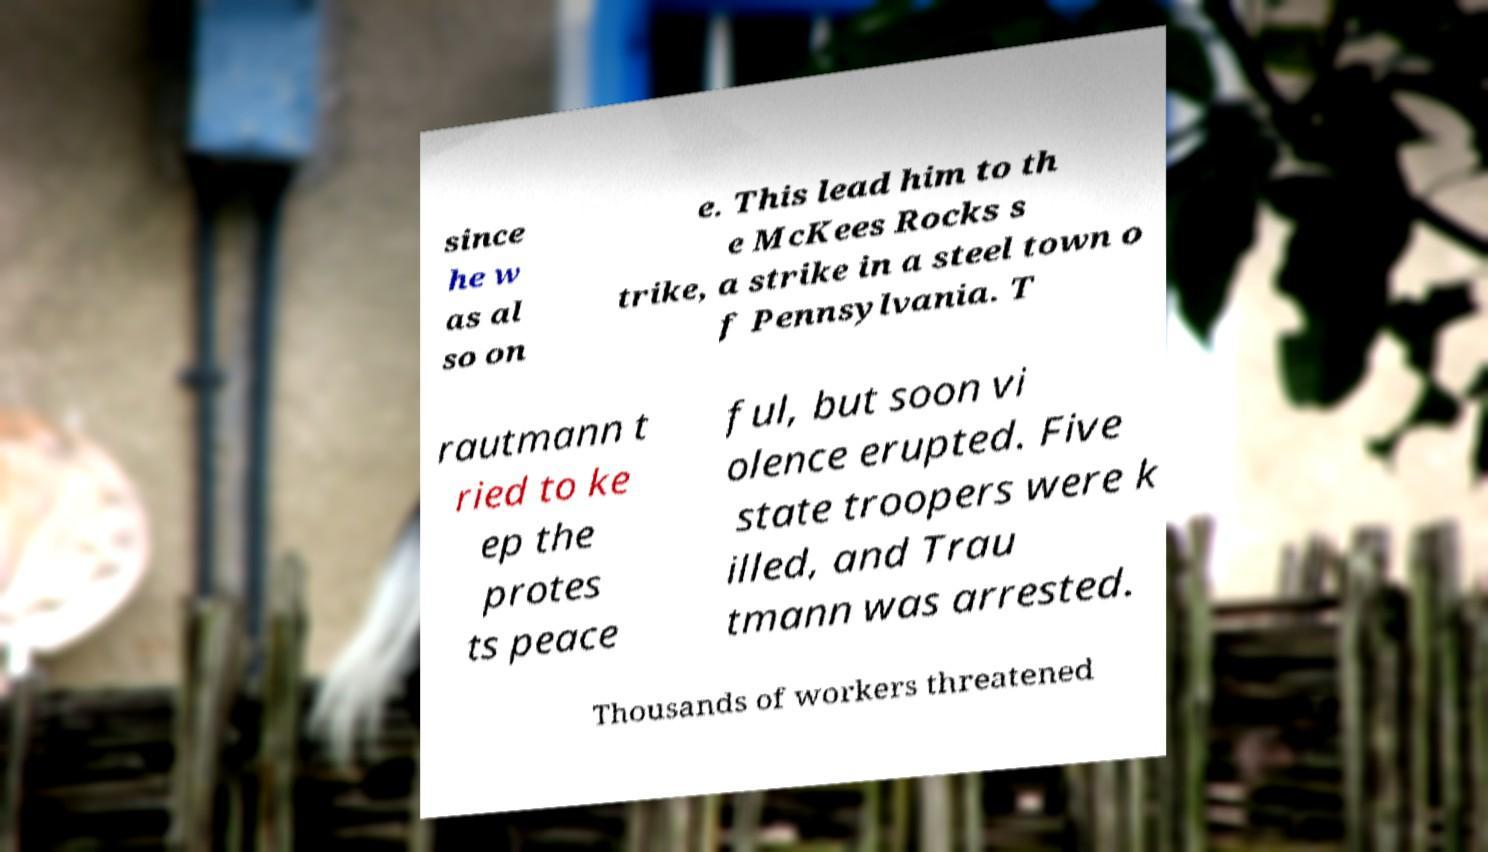There's text embedded in this image that I need extracted. Can you transcribe it verbatim? since he w as al so on e. This lead him to th e McKees Rocks s trike, a strike in a steel town o f Pennsylvania. T rautmann t ried to ke ep the protes ts peace ful, but soon vi olence erupted. Five state troopers were k illed, and Trau tmann was arrested. Thousands of workers threatened 